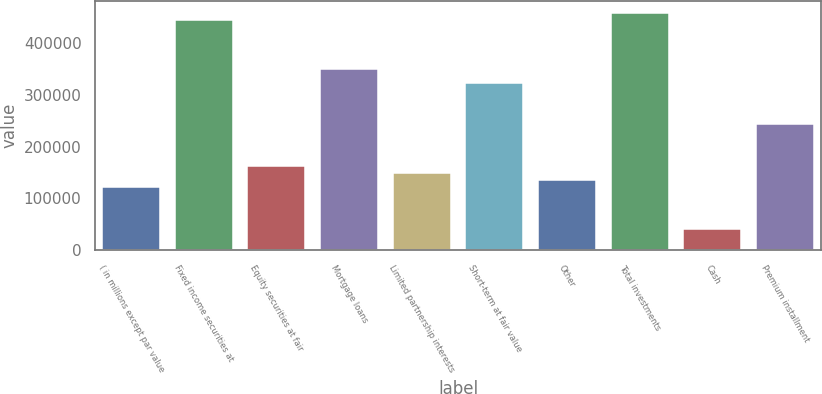<chart> <loc_0><loc_0><loc_500><loc_500><bar_chart><fcel>( in millions except par value<fcel>Fixed income securities at<fcel>Equity securities at fair<fcel>Mortgage loans<fcel>Limited partnership interests<fcel>Short-term at fair value<fcel>Other<fcel>Total investments<fcel>Cash<fcel>Premium installment<nl><fcel>121319<fcel>444822<fcel>161757<fcel>350467<fcel>148277<fcel>323508<fcel>134798<fcel>458301<fcel>40442.9<fcel>242632<nl></chart> 